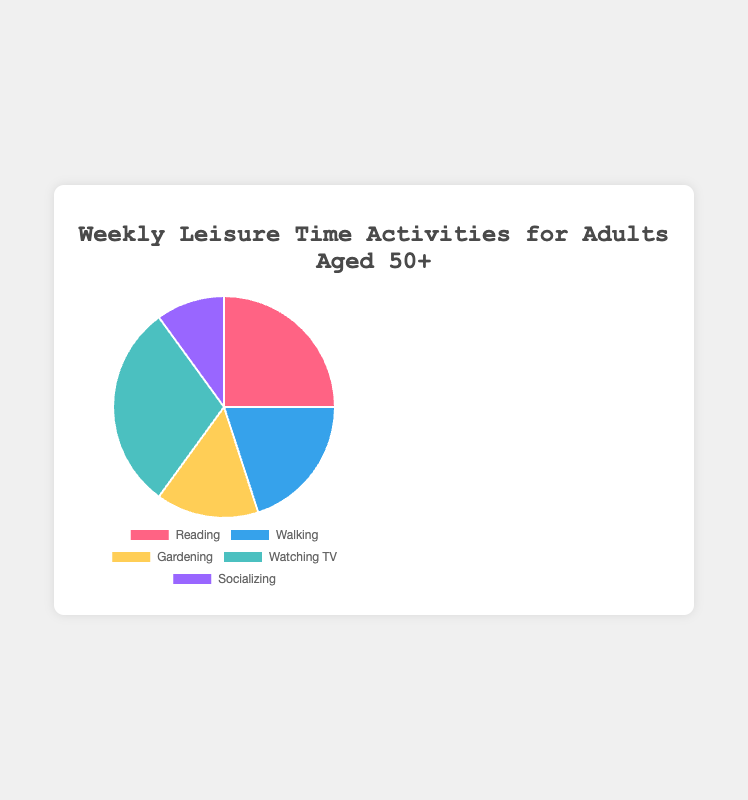Which activity has the largest percentage share? Look at the pie chart segments and compare their sizes. The segment with the largest size represents the activity with the largest percentage share. In this case, "Watching TV" has the largest segment.
Answer: Watching TV How much more time is spent reading compared to socializing? Find the percentage for "Reading" and "Socializing." Subtract the smaller percentage (10% for Socializing) from the larger one (25% for Reading). 25 - 10 is 15.
Answer: 15% Which activities make up half of the chart combined? Add the percentages of "Watching TV" (30%) and "Reading" (25%) first. 30 + 25 equals 55, which is more than half. Now, try "Watching TV" (30%) and "Walking" (20%); their sum is 50%. Two activities that combine exactly to half the chart are "Watching TV" and "Walking."
Answer: Watching TV and Walking What's the sum of the time spent on Walking and Gardening? Look at the chart to find the percentages for Walking (20%) and Gardening (15%). Add these percentages together: 20 + 15 = 35.
Answer: 35% Which activity has the smallest percentage share? Look at the pie chart and identify the smallest segment by visual comparison. The smallest segment corresponds to "Socializing."
Answer: Socializing What is the difference in percentage points between the highest and lowest activities? Identify the highest percentage (Watching TV, 30%) and the lowest percentage (Socializing, 10%). Subtract the lowest from the highest: 30 - 10 = 20.
Answer: 20 percentage points Which activity is represented by a green color in the chart? Look at the chart and match each activity's segment color with the description. Green corresponds to "Walking."
Answer: Walking How much less is the percentage for Gardening compared to Watching TV? Note the percentages for Gardening (15%) and Watching TV (30%). Subtract the percentage of Gardening from that of Watching TV: 30 - 15 = 15.
Answer: 15% What is the average time spent on Reading, Walking, and Gardening? Add the three percentages: 25% + 20% + 15% = 60%. Then, divide by the number of activities (3): 60 / 3 = 20%.
Answer: 20% How do Walking and Gardening combined compare to Reading alone? Combine the percentages for Walking (20%) and Gardening (15%): 20 + 15 = 35%. Reading alone is 25%. Compare the two, and you will see that Walking and Gardening combined dominate Reading alone by 10%.
Answer: 35% is 10% more than 25% 